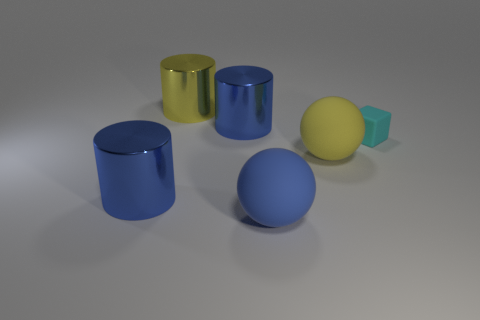There is a metallic thing that is both in front of the yellow metallic cylinder and behind the matte block; what size is it?
Your answer should be compact. Large. Are there more objects that are on the right side of the yellow cylinder than large blue shiny objects that are on the right side of the tiny thing?
Ensure brevity in your answer.  Yes. Does the big yellow metal object have the same shape as the large blue shiny object that is in front of the big yellow rubber sphere?
Your answer should be very brief. Yes. How many other things are there of the same shape as the small cyan matte thing?
Ensure brevity in your answer.  0. There is a thing that is right of the big yellow cylinder and behind the tiny cube; what color is it?
Keep it short and to the point. Blue. The tiny rubber thing is what color?
Your response must be concise. Cyan. Does the block have the same material as the big yellow object that is on the right side of the yellow cylinder?
Ensure brevity in your answer.  Yes. The large yellow object that is the same material as the large blue sphere is what shape?
Your response must be concise. Sphere. What color is the other matte sphere that is the same size as the yellow ball?
Your answer should be compact. Blue. There is a metallic thing that is in front of the yellow rubber thing; is its size the same as the big yellow sphere?
Offer a terse response. Yes. 